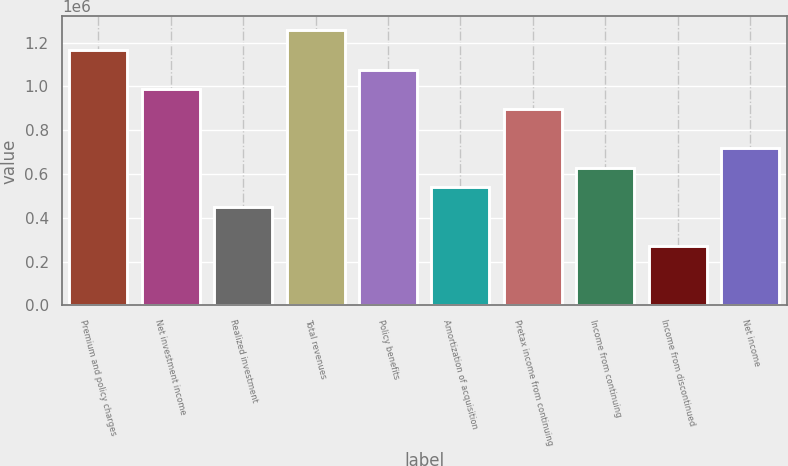Convert chart. <chart><loc_0><loc_0><loc_500><loc_500><bar_chart><fcel>Premium and policy charges<fcel>Net investment income<fcel>Realized investment<fcel>Total revenues<fcel>Policy benefits<fcel>Amortization of acquisition<fcel>Pretax income from continuing<fcel>Income from continuing<fcel>Income from discontinued<fcel>Net income<nl><fcel>1.1673e+06<fcel>987715<fcel>448962<fcel>1.25709e+06<fcel>1.07751e+06<fcel>538754<fcel>897923<fcel>628546<fcel>269378<fcel>718339<nl></chart> 